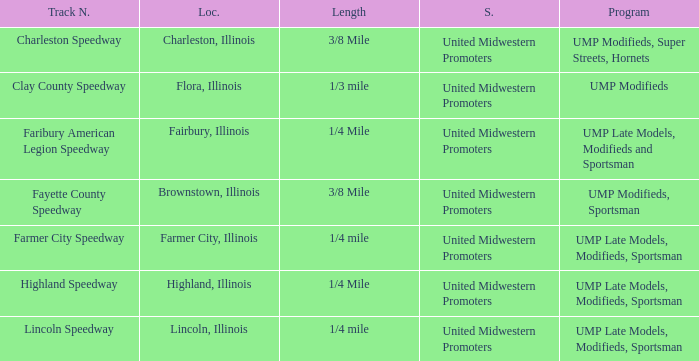Who sanctioned the event in lincoln, illinois? United Midwestern Promoters. 